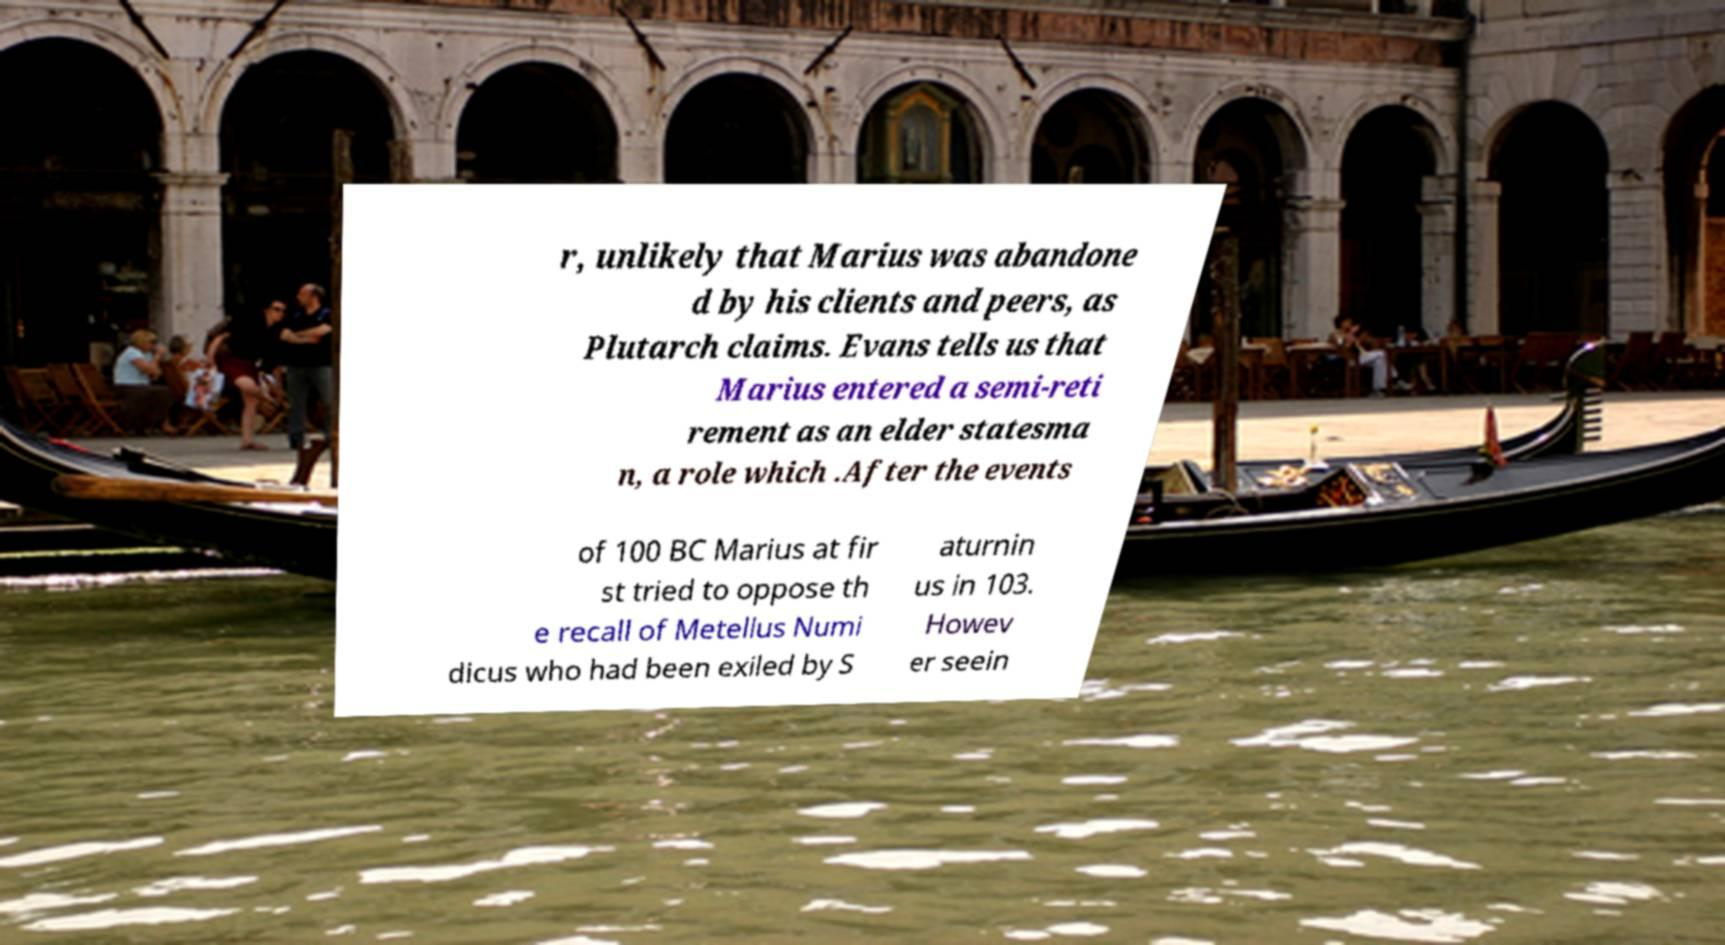What messages or text are displayed in this image? I need them in a readable, typed format. r, unlikely that Marius was abandone d by his clients and peers, as Plutarch claims. Evans tells us that Marius entered a semi-reti rement as an elder statesma n, a role which .After the events of 100 BC Marius at fir st tried to oppose th e recall of Metellus Numi dicus who had been exiled by S aturnin us in 103. Howev er seein 